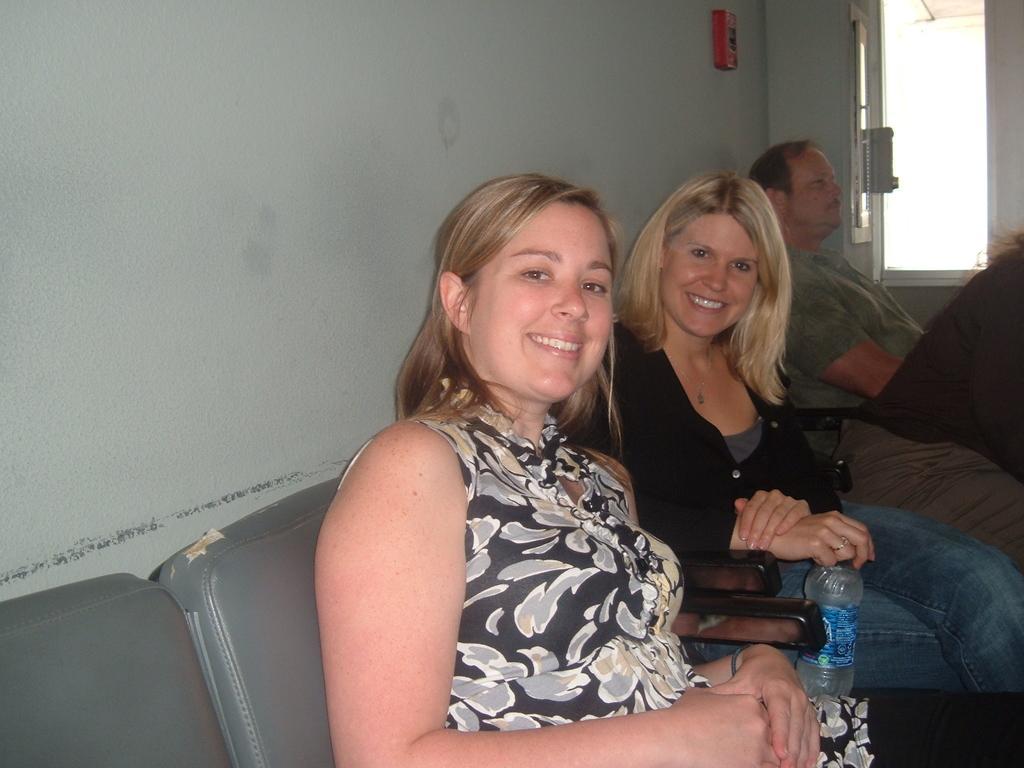In one or two sentences, can you explain what this image depicts? There are 4 people sitting on the chair,2 of them are women smiling. 